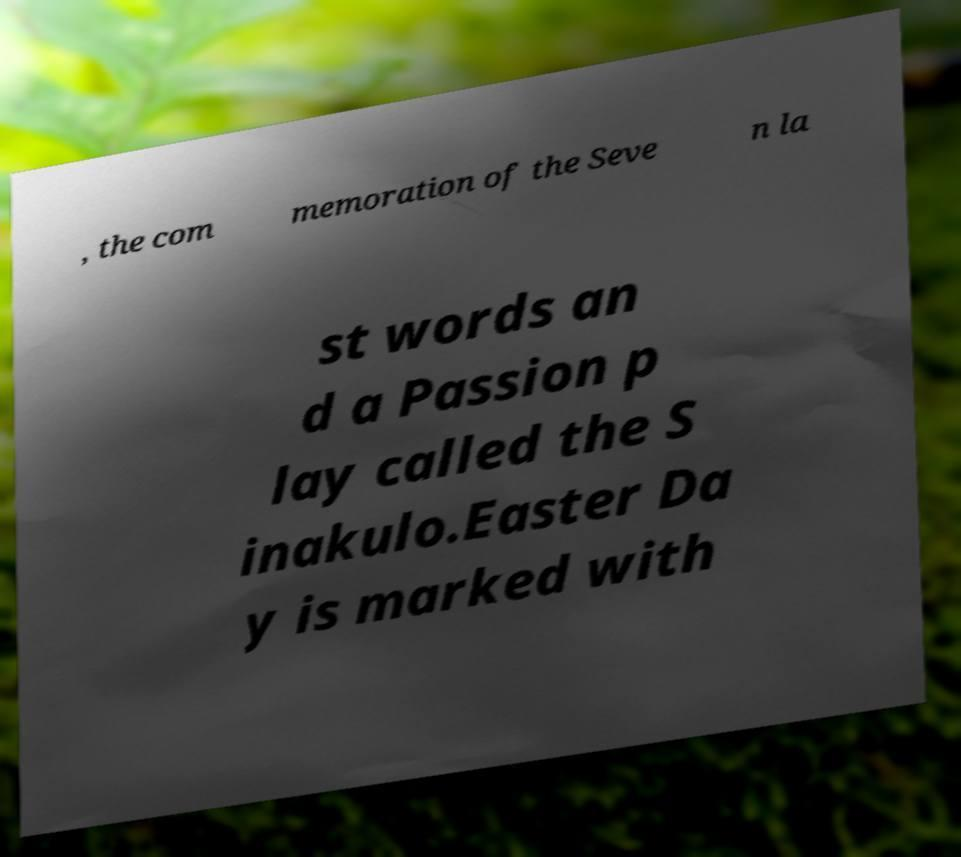Could you assist in decoding the text presented in this image and type it out clearly? , the com memoration of the Seve n la st words an d a Passion p lay called the S inakulo.Easter Da y is marked with 